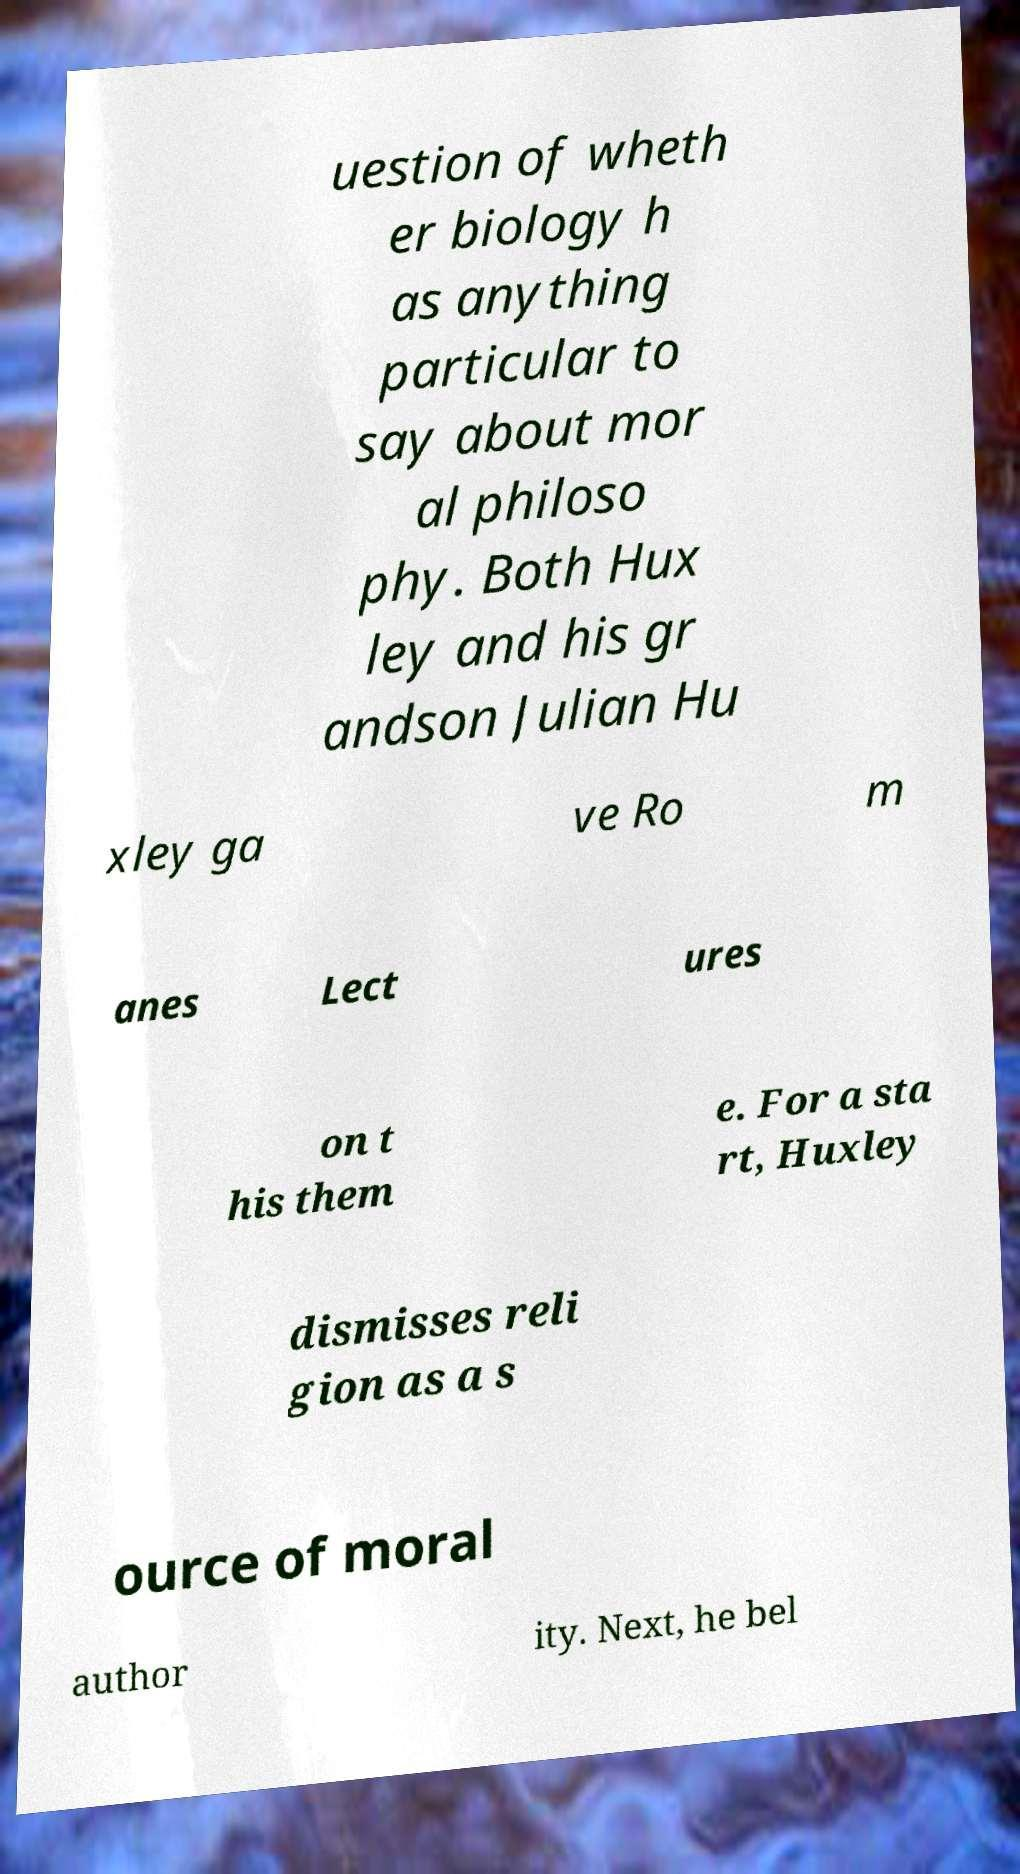Could you extract and type out the text from this image? uestion of wheth er biology h as anything particular to say about mor al philoso phy. Both Hux ley and his gr andson Julian Hu xley ga ve Ro m anes Lect ures on t his them e. For a sta rt, Huxley dismisses reli gion as a s ource of moral author ity. Next, he bel 